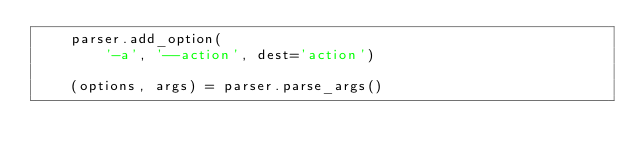<code> <loc_0><loc_0><loc_500><loc_500><_Python_>    parser.add_option(
        '-a', '--action', dest='action')

    (options, args) = parser.parse_args()
</code> 